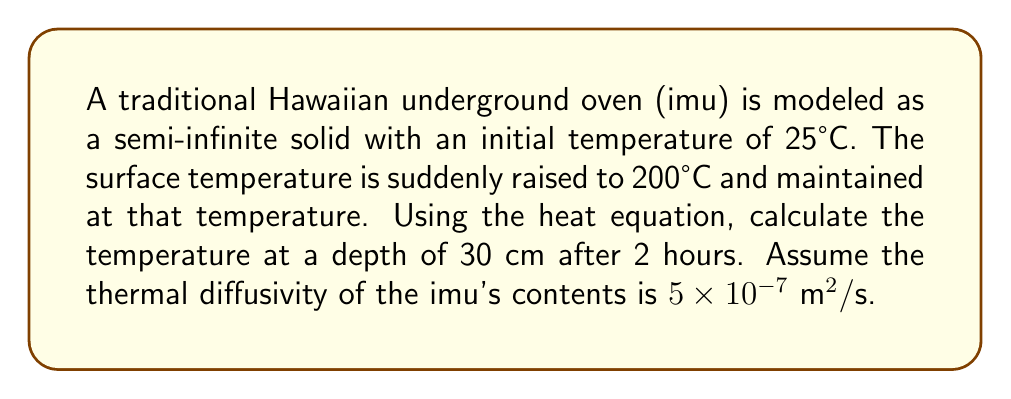What is the answer to this math problem? 1) The heat equation for a semi-infinite solid with a constant surface temperature is:

   $$T(x,t) = T_i + (T_s - T_i) \text{erfc}\left(\frac{x}{2\sqrt{\alpha t}}\right)$$

   where:
   $T(x,t)$ is the temperature at depth $x$ and time $t$
   $T_i$ is the initial temperature
   $T_s$ is the surface temperature
   $\alpha$ is the thermal diffusivity
   erfc is the complementary error function

2) Given:
   $T_i = 25°\text{C}$
   $T_s = 200°\text{C}$
   $x = 30 \text{ cm} = 0.3 \text{ m}$
   $t = 2 \text{ hours} = 7200 \text{ s}$
   $\alpha = 5 \times 10^{-7} \text{ m}^2/\text{s}$

3) Calculate the argument of the erfc function:

   $$\frac{x}{2\sqrt{\alpha t}} = \frac{0.3}{2\sqrt{(5 \times 10^{-7})(7200)}} \approx 0.7906$$

4) Look up the value of erfc(0.7906) in a table or use a calculator:

   $$\text{erfc}(0.7906) \approx 0.2388$$

5) Substitute all values into the equation:

   $$T(0.3, 7200) = 25 + (200 - 25)(0.2388)$$

6) Solve:

   $$T(0.3, 7200) = 25 + 175(0.2388) = 25 + 41.79 = 66.79°\text{C}$$
Answer: $66.79°\text{C}$ 